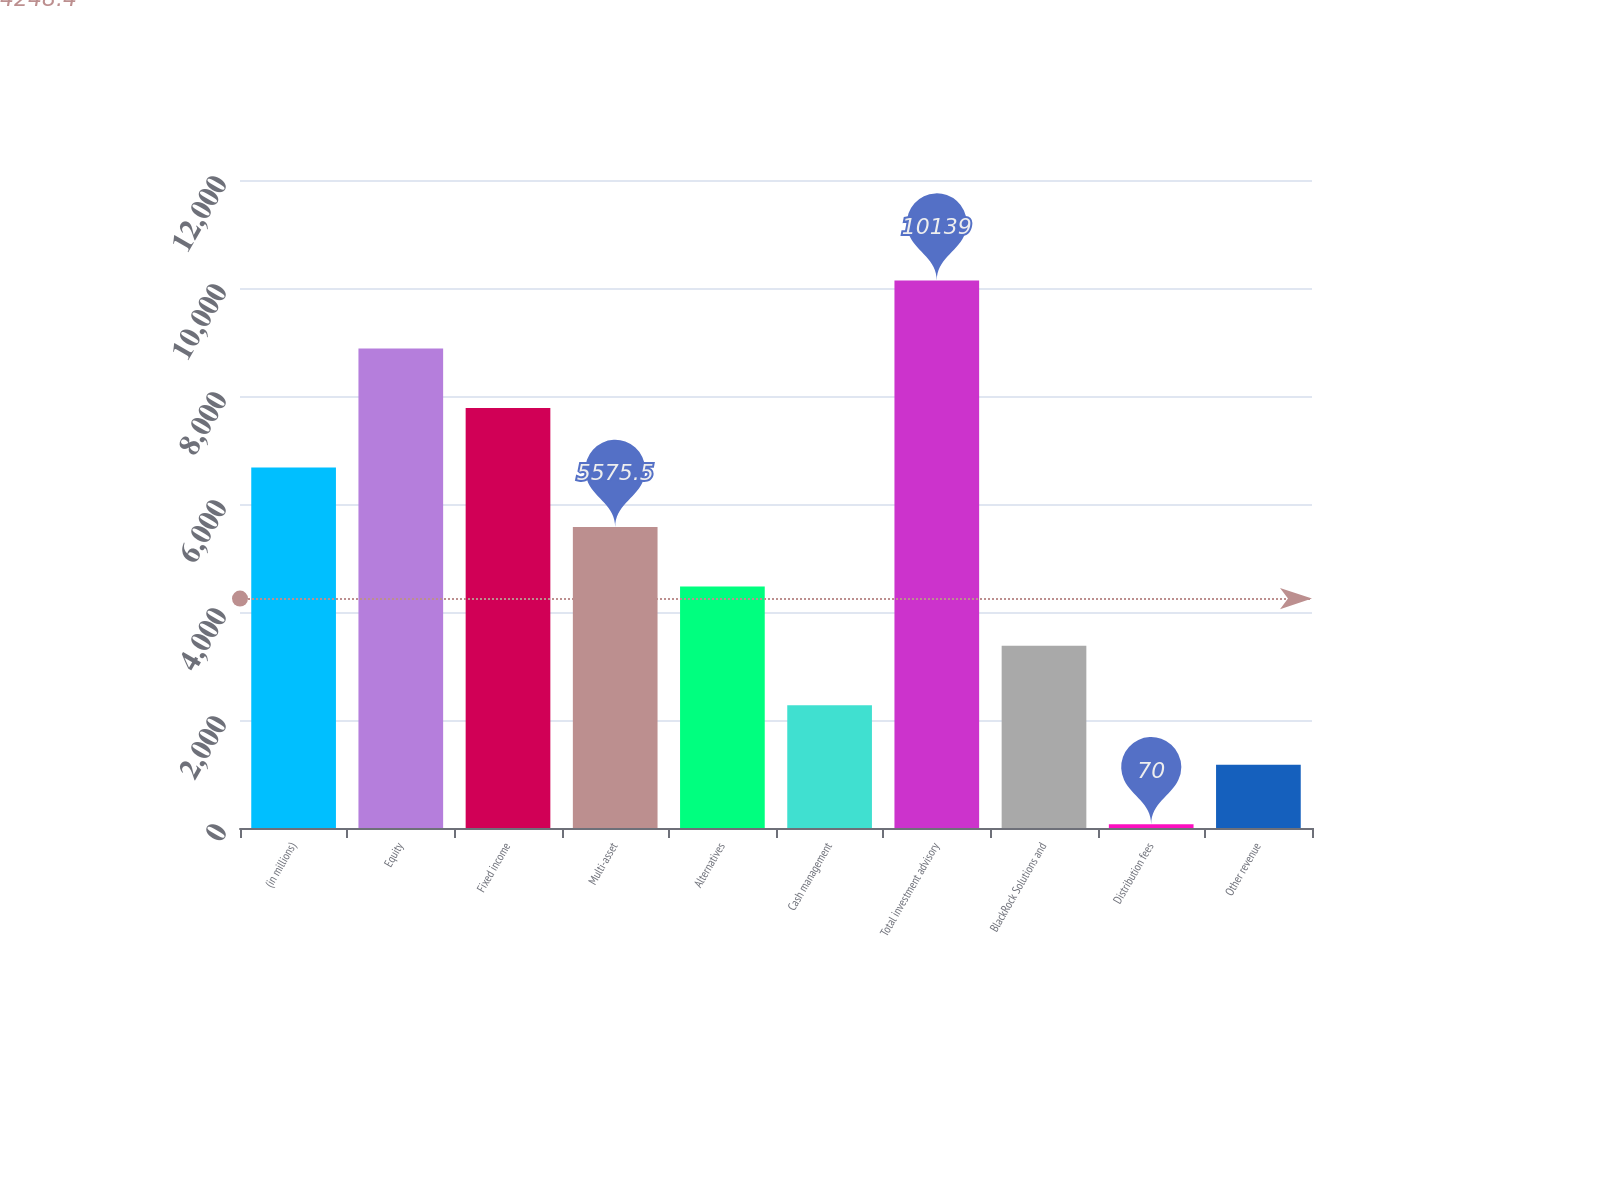<chart> <loc_0><loc_0><loc_500><loc_500><bar_chart><fcel>(in millions)<fcel>Equity<fcel>Fixed income<fcel>Multi-asset<fcel>Alternatives<fcel>Cash management<fcel>Total investment advisory<fcel>BlackRock Solutions and<fcel>Distribution fees<fcel>Other revenue<nl><fcel>6676.6<fcel>8878.8<fcel>7777.7<fcel>5575.5<fcel>4474.4<fcel>2272.2<fcel>10139<fcel>3373.3<fcel>70<fcel>1171.1<nl></chart> 